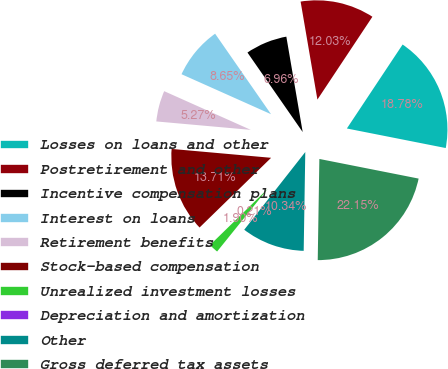Convert chart. <chart><loc_0><loc_0><loc_500><loc_500><pie_chart><fcel>Losses on loans and other<fcel>Postretirement and other<fcel>Incentive compensation plans<fcel>Interest on loans<fcel>Retirement benefits<fcel>Stock-based compensation<fcel>Unrealized investment losses<fcel>Depreciation and amortization<fcel>Other<fcel>Gross deferred tax assets<nl><fcel>18.78%<fcel>12.03%<fcel>6.96%<fcel>8.65%<fcel>5.27%<fcel>13.71%<fcel>1.9%<fcel>0.21%<fcel>10.34%<fcel>22.15%<nl></chart> 